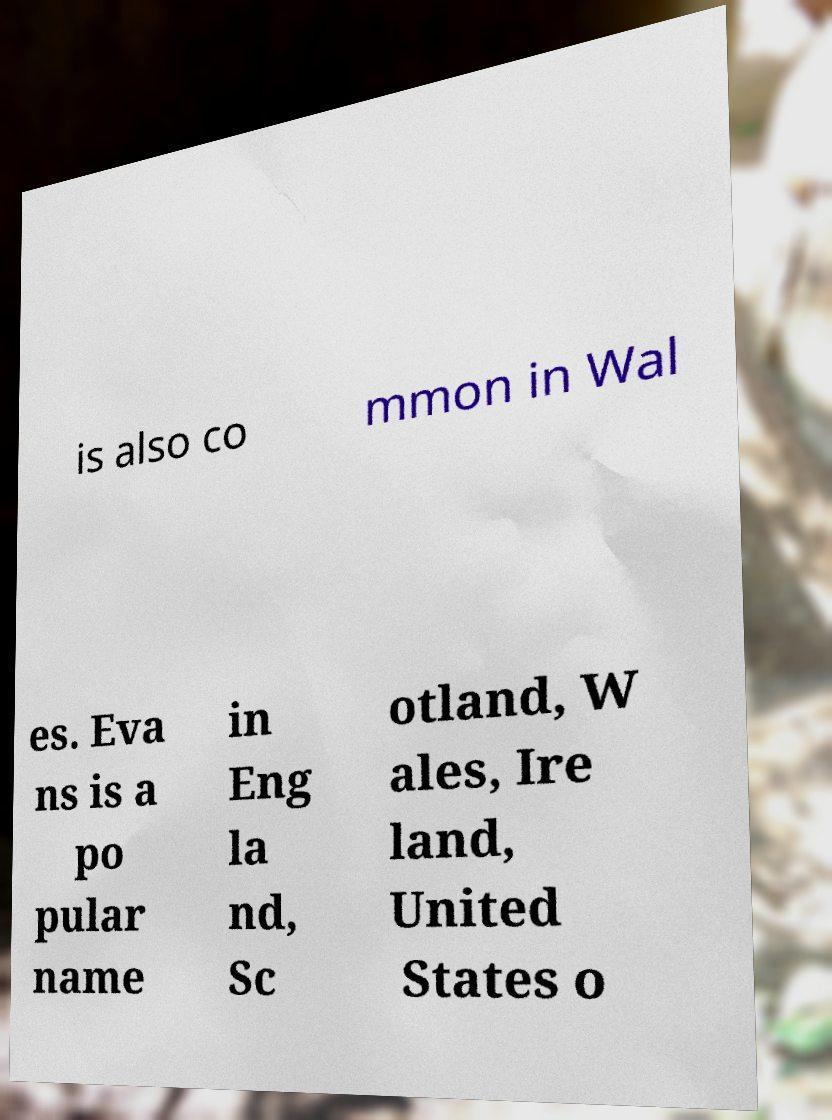Could you extract and type out the text from this image? is also co mmon in Wal es. Eva ns is a po pular name in Eng la nd, Sc otland, W ales, Ire land, United States o 